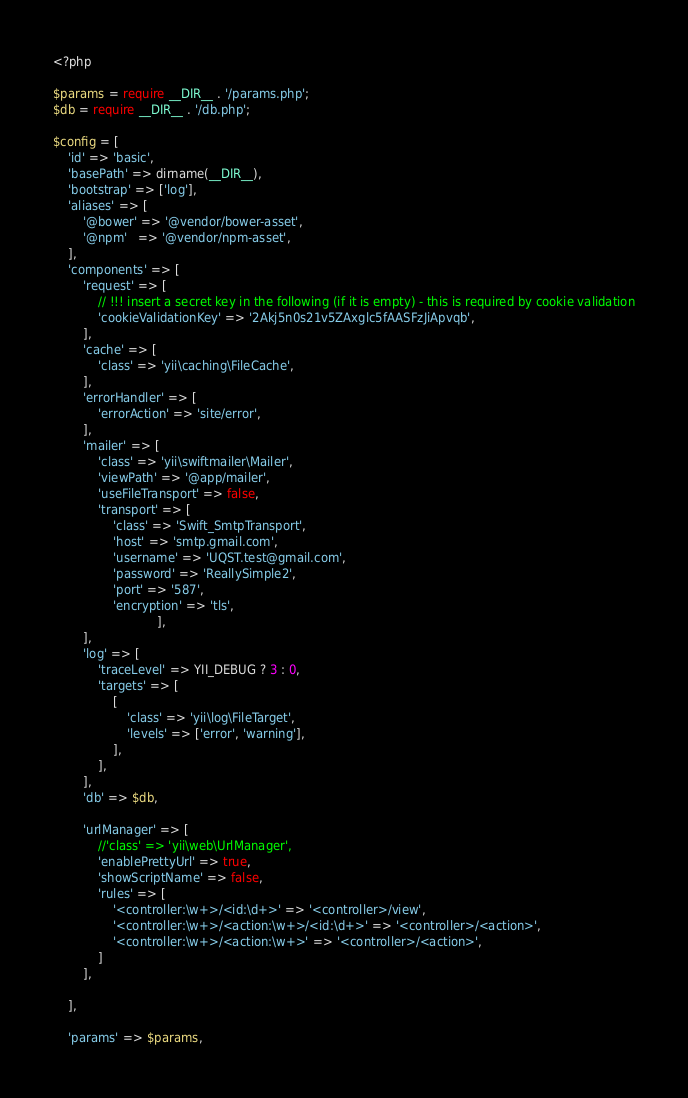Convert code to text. <code><loc_0><loc_0><loc_500><loc_500><_PHP_><?php

$params = require __DIR__ . '/params.php';
$db = require __DIR__ . '/db.php';

$config = [
    'id' => 'basic',
    'basePath' => dirname(__DIR__),
    'bootstrap' => ['log'],
    'aliases' => [
        '@bower' => '@vendor/bower-asset',
        '@npm'   => '@vendor/npm-asset',
    ],
    'components' => [
        'request' => [
            // !!! insert a secret key in the following (if it is empty) - this is required by cookie validation
            'cookieValidationKey' => '2Akj5n0s21v5ZAxglc5fAASFzJiApvqb',
        ],
        'cache' => [
            'class' => 'yii\caching\FileCache',
        ],
        'errorHandler' => [
            'errorAction' => 'site/error',
        ],
        'mailer' => [
            'class' => 'yii\swiftmailer\Mailer',
            'viewPath' => '@app/mailer',
            'useFileTransport' => false,
            'transport' => [
                'class' => 'Swift_SmtpTransport',
                'host' => 'smtp.gmail.com', 
                'username' => 'UQST.test@gmail.com',
                'password' => 'ReallySimple2',
                'port' => '587', 
                'encryption' => 'tls',
                            ],
        ],
        'log' => [
            'traceLevel' => YII_DEBUG ? 3 : 0,
            'targets' => [
                [
                    'class' => 'yii\log\FileTarget',
                    'levels' => ['error', 'warning'],
                ],
            ],
        ],
        'db' => $db,
        
        'urlManager' => [
            //'class' => 'yii\web\UrlManager',
            'enablePrettyUrl' => true,
            'showScriptName' => false,
            'rules' => [
                '<controller:\w+>/<id:\d+>' => '<controller>/view',
                '<controller:\w+>/<action:\w+>/<id:\d+>' => '<controller>/<action>',
                '<controller:\w+>/<action:\w+>' => '<controller>/<action>',
            ]
        ],
        
    ],
    
    'params' => $params,
</code> 